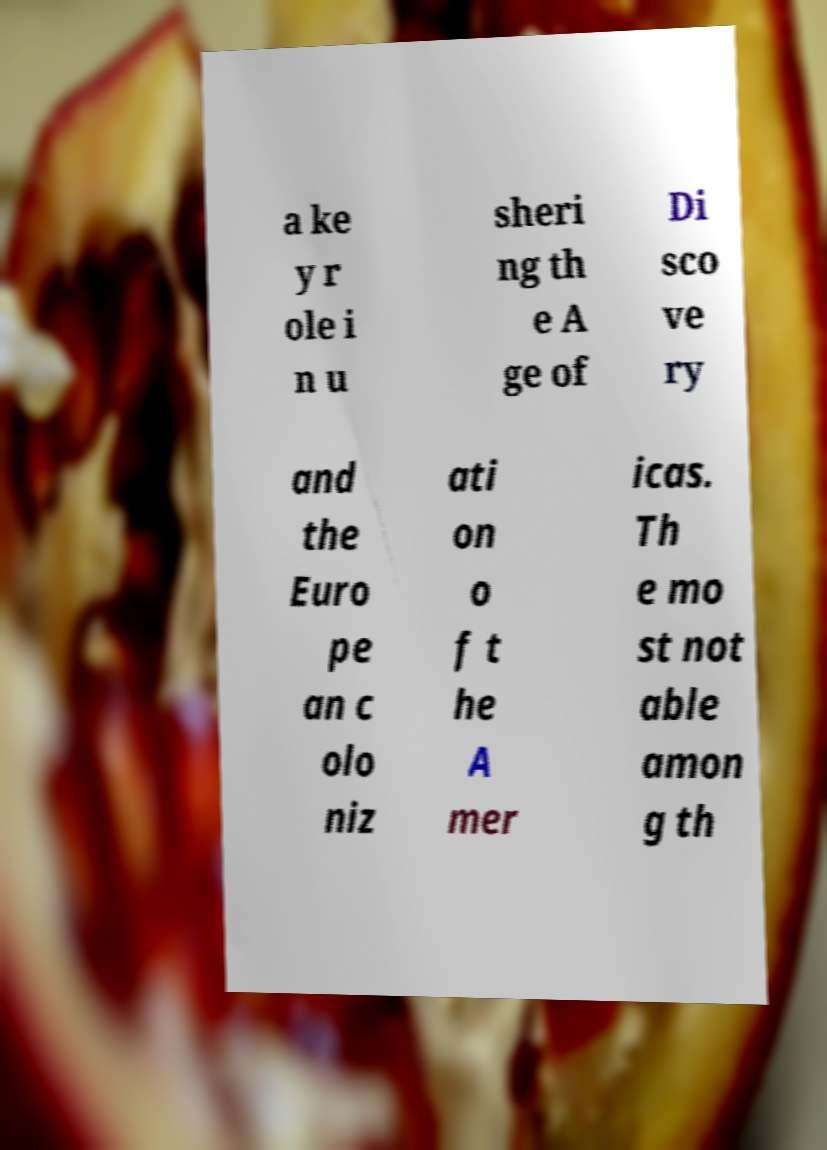Can you read and provide the text displayed in the image?This photo seems to have some interesting text. Can you extract and type it out for me? a ke y r ole i n u sheri ng th e A ge of Di sco ve ry and the Euro pe an c olo niz ati on o f t he A mer icas. Th e mo st not able amon g th 